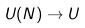<formula> <loc_0><loc_0><loc_500><loc_500>U ( N ) \rightarrow U</formula> 